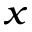Convert formula to latex. <formula><loc_0><loc_0><loc_500><loc_500>_ { x }</formula> 